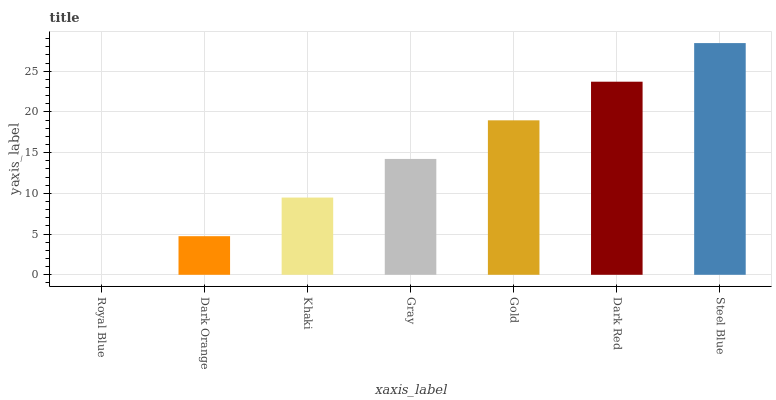Is Royal Blue the minimum?
Answer yes or no. Yes. Is Steel Blue the maximum?
Answer yes or no. Yes. Is Dark Orange the minimum?
Answer yes or no. No. Is Dark Orange the maximum?
Answer yes or no. No. Is Dark Orange greater than Royal Blue?
Answer yes or no. Yes. Is Royal Blue less than Dark Orange?
Answer yes or no. Yes. Is Royal Blue greater than Dark Orange?
Answer yes or no. No. Is Dark Orange less than Royal Blue?
Answer yes or no. No. Is Gray the high median?
Answer yes or no. Yes. Is Gray the low median?
Answer yes or no. Yes. Is Dark Red the high median?
Answer yes or no. No. Is Steel Blue the low median?
Answer yes or no. No. 